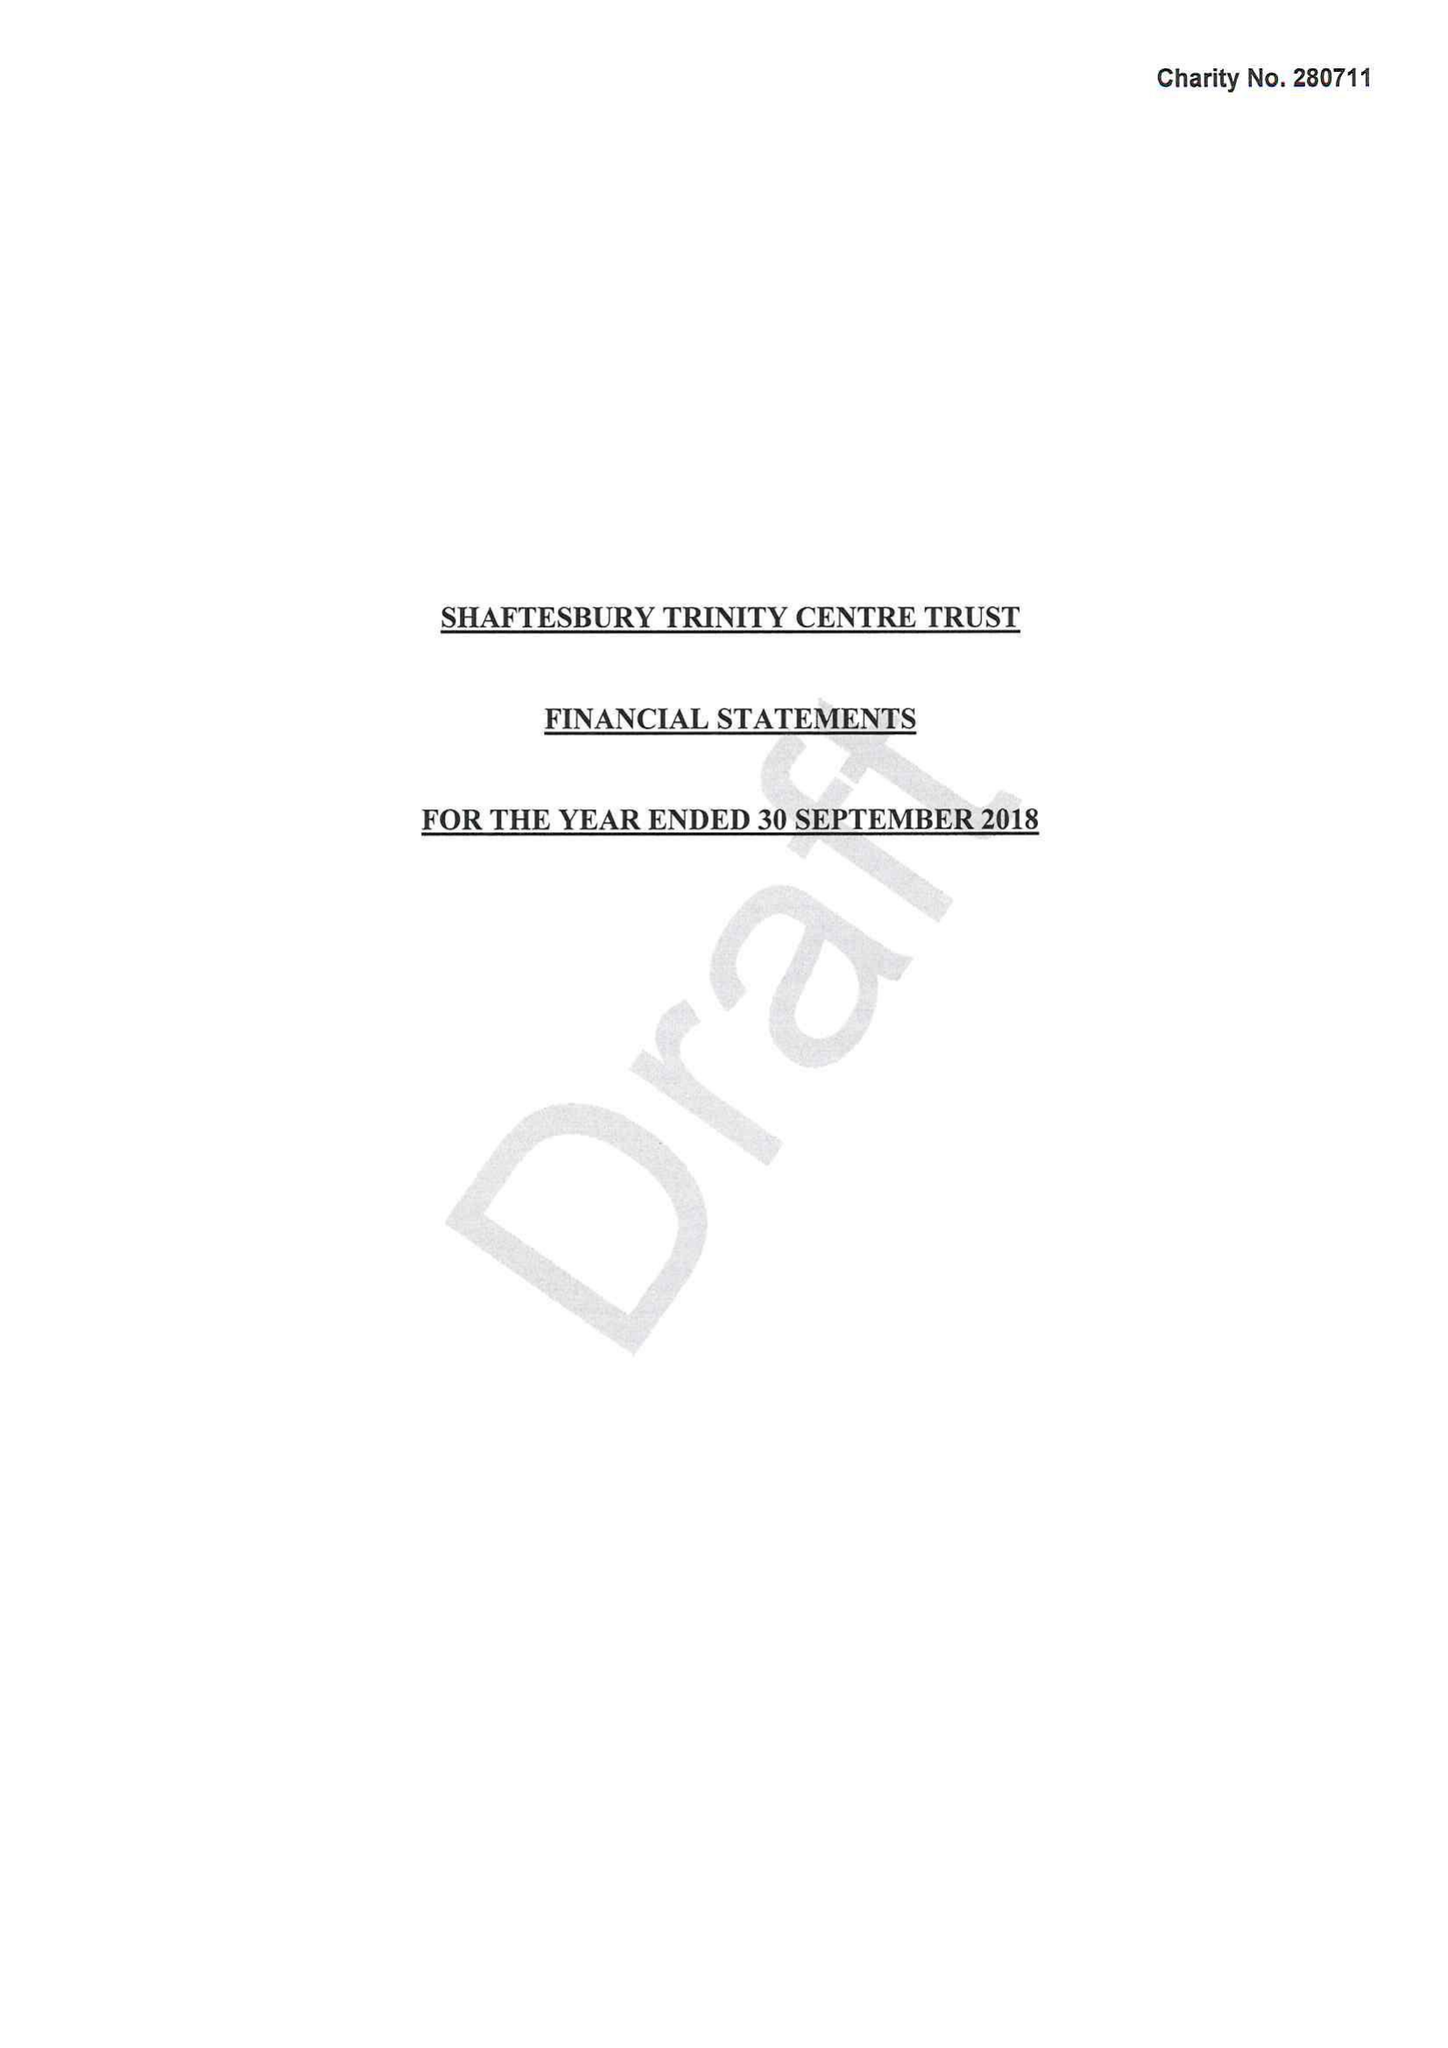What is the value for the report_date?
Answer the question using a single word or phrase. 2018-09-30 